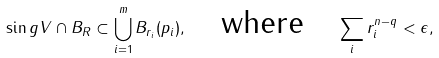<formula> <loc_0><loc_0><loc_500><loc_500>\sin g V \cap B _ { R } \subset \bigcup _ { i = 1 } ^ { m } B _ { r _ { i } } ( p _ { i } ) , \quad \text {where} \quad \sum _ { i } r _ { i } ^ { n - q } < \epsilon ,</formula> 